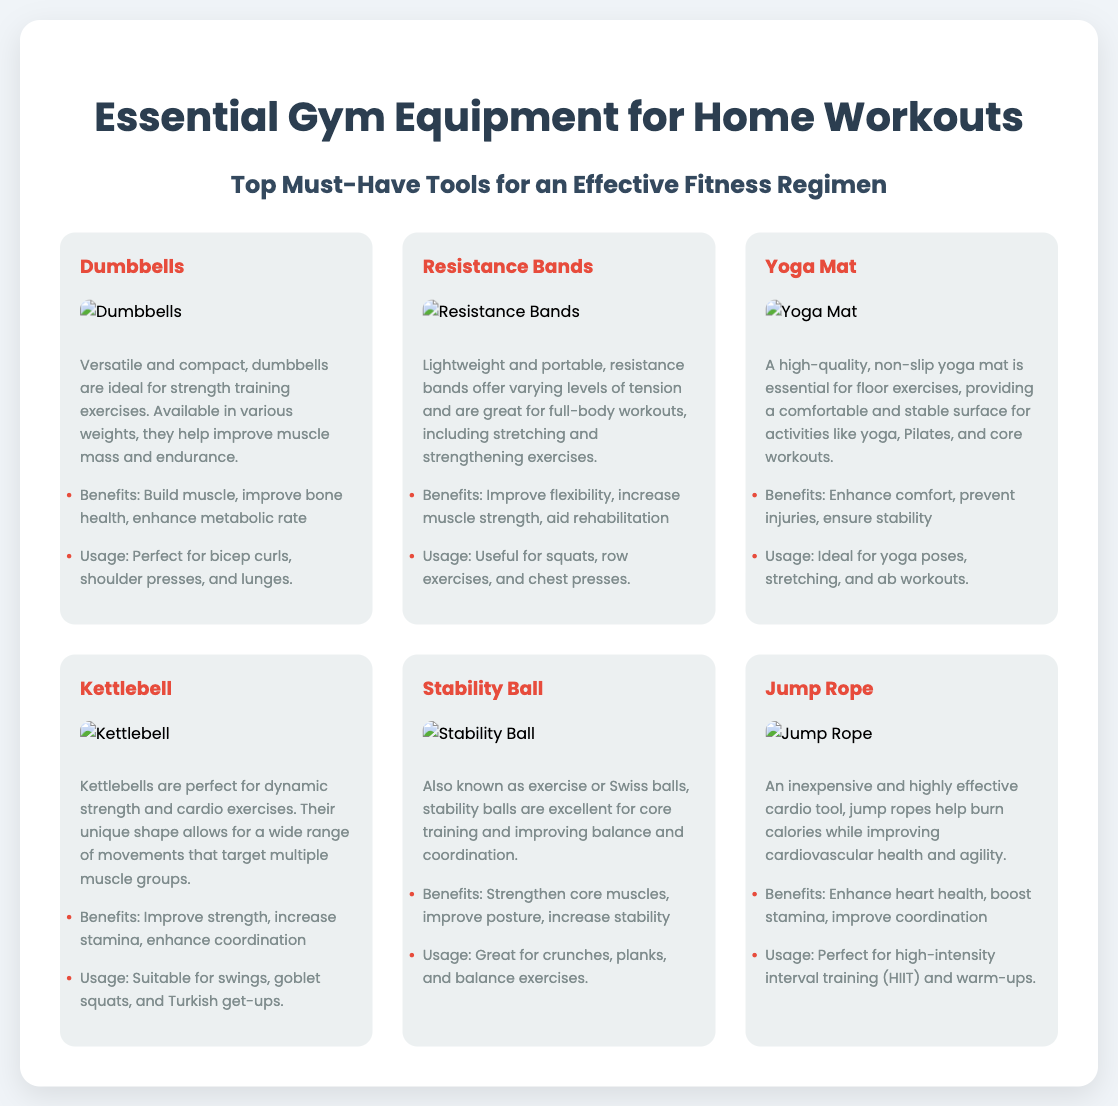What is the title of the poster? The title is a prominent heading displayed at the top of the document.
Answer: Essential Gym Equipment for Home Workouts How many pieces of equipment are featured in the poster? The number of equipment items can be counted from the grid layout showing each item.
Answer: Six What color is the background of the poster? The background color is specified in the document's styling section.
Answer: Light gray Which equipment is described as ideal for strength training? The description mentions specific benefits related to strength training.
Answer: Dumbbells What are the benefits of using resistance bands? The benefits listed address various aspects of using resistance bands for workouts.
Answer: Improve flexibility, increase muscle strength, aid rehabilitation What exercise is suggested for stability balls? The usage section provides examples of workouts that utilize stability balls.
Answer: Crunches What type of material is the yoga mat made of? The document specifies the quality of the yoga mat used for exercises.
Answer: Non-slip Which equipment is highlighted for cardio workouts? The document specifically indicates a piece of equipment used primarily for cardio.
Answer: Jump Rope What is a unique feature of kettlebells? The description points out a notable aspect of kettlebells concerning their shape and usage.
Answer: Dynamic strength and cardio exercises What is the primary benefit of using a stability ball? The benefits section explains the main advantage of incorporating a stability ball into workouts.
Answer: Strengthen core muscles 